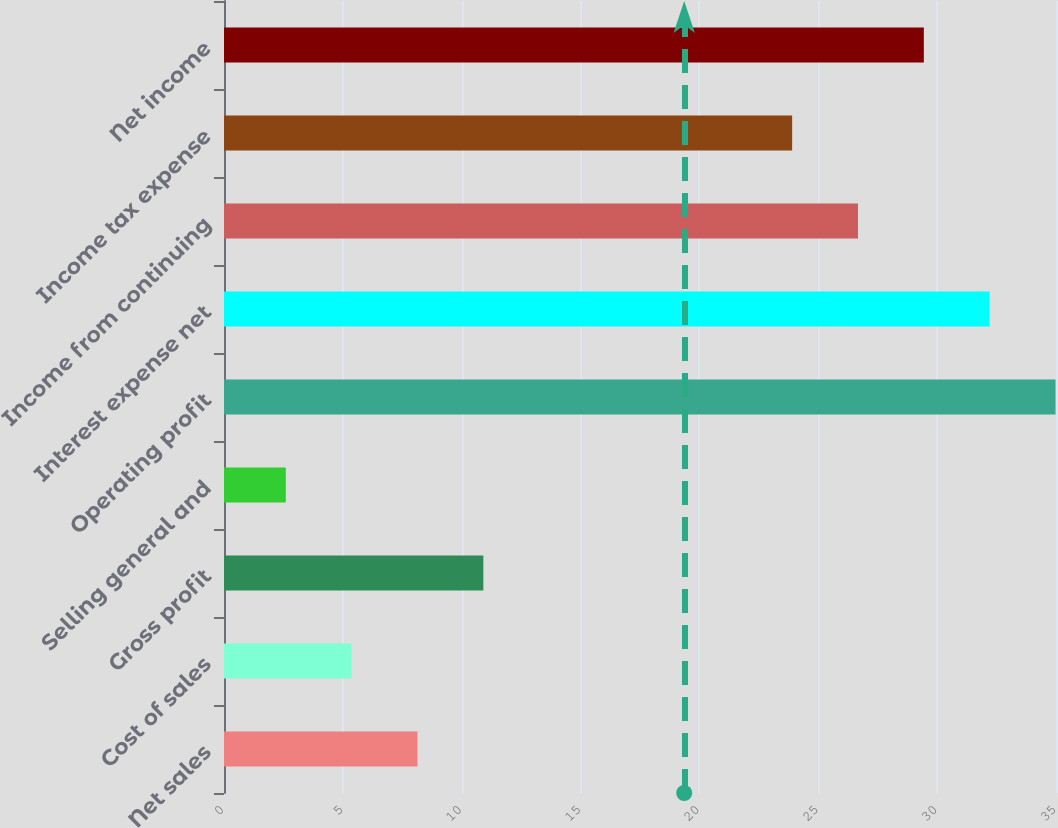Convert chart. <chart><loc_0><loc_0><loc_500><loc_500><bar_chart><fcel>Net sales<fcel>Cost of sales<fcel>Gross profit<fcel>Selling general and<fcel>Operating profit<fcel>Interest expense net<fcel>Income from continuing<fcel>Income tax expense<fcel>Net income<nl><fcel>8.14<fcel>5.37<fcel>10.91<fcel>2.6<fcel>34.98<fcel>32.21<fcel>26.67<fcel>23.9<fcel>29.44<nl></chart> 